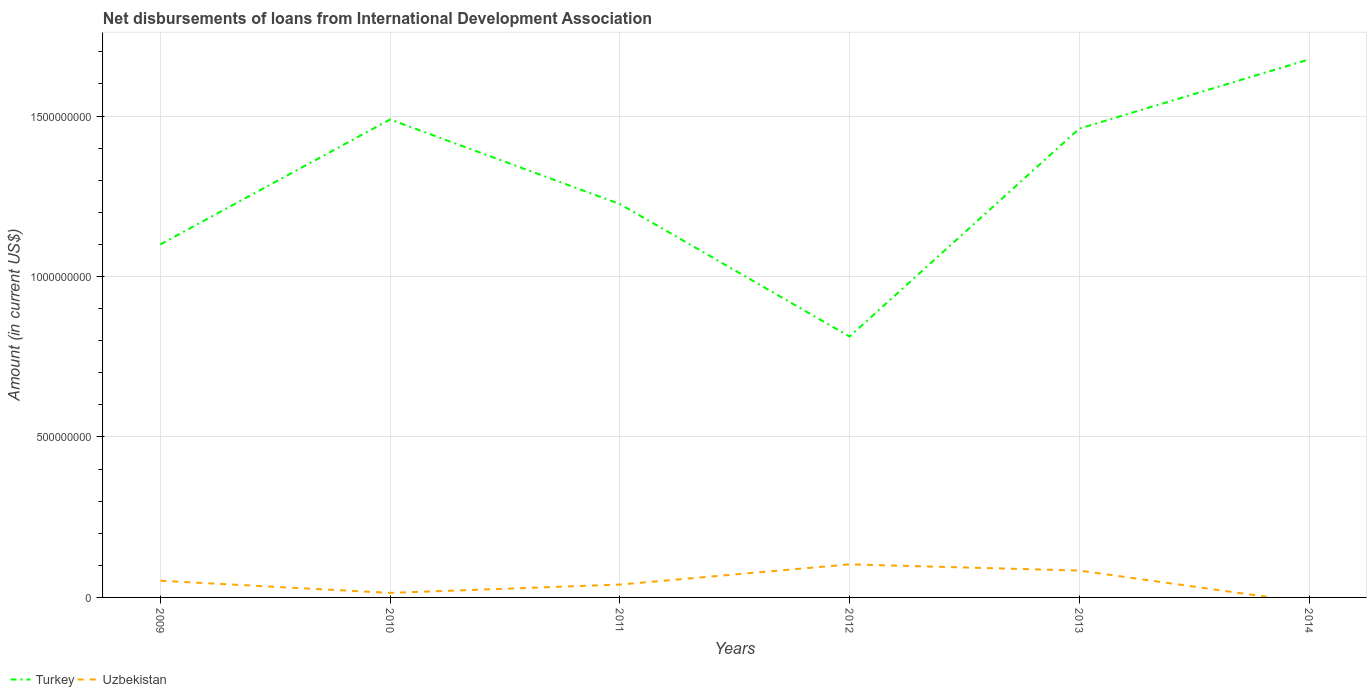How many different coloured lines are there?
Give a very brief answer. 2. What is the total amount of loans disbursed in Uzbekistan in the graph?
Your response must be concise. -3.16e+07. What is the difference between the highest and the second highest amount of loans disbursed in Uzbekistan?
Keep it short and to the point. 1.03e+08. What is the difference between the highest and the lowest amount of loans disbursed in Uzbekistan?
Make the answer very short. 3. How many years are there in the graph?
Offer a terse response. 6. Are the values on the major ticks of Y-axis written in scientific E-notation?
Ensure brevity in your answer.  No. Does the graph contain any zero values?
Your answer should be compact. Yes. How many legend labels are there?
Ensure brevity in your answer.  2. What is the title of the graph?
Give a very brief answer. Net disbursements of loans from International Development Association. What is the label or title of the X-axis?
Keep it short and to the point. Years. What is the Amount (in current US$) of Turkey in 2009?
Your answer should be compact. 1.10e+09. What is the Amount (in current US$) of Uzbekistan in 2009?
Make the answer very short. 5.20e+07. What is the Amount (in current US$) in Turkey in 2010?
Ensure brevity in your answer.  1.49e+09. What is the Amount (in current US$) of Uzbekistan in 2010?
Provide a succinct answer. 1.41e+07. What is the Amount (in current US$) of Turkey in 2011?
Your response must be concise. 1.23e+09. What is the Amount (in current US$) of Uzbekistan in 2011?
Your answer should be compact. 4.01e+07. What is the Amount (in current US$) of Turkey in 2012?
Provide a succinct answer. 8.13e+08. What is the Amount (in current US$) in Uzbekistan in 2012?
Offer a very short reply. 1.03e+08. What is the Amount (in current US$) of Turkey in 2013?
Your answer should be very brief. 1.46e+09. What is the Amount (in current US$) in Uzbekistan in 2013?
Your answer should be very brief. 8.37e+07. What is the Amount (in current US$) of Turkey in 2014?
Your answer should be compact. 1.68e+09. Across all years, what is the maximum Amount (in current US$) in Turkey?
Make the answer very short. 1.68e+09. Across all years, what is the maximum Amount (in current US$) in Uzbekistan?
Offer a terse response. 1.03e+08. Across all years, what is the minimum Amount (in current US$) of Turkey?
Keep it short and to the point. 8.13e+08. Across all years, what is the minimum Amount (in current US$) of Uzbekistan?
Offer a terse response. 0. What is the total Amount (in current US$) in Turkey in the graph?
Your response must be concise. 7.76e+09. What is the total Amount (in current US$) of Uzbekistan in the graph?
Your answer should be very brief. 2.93e+08. What is the difference between the Amount (in current US$) in Turkey in 2009 and that in 2010?
Your answer should be compact. -3.89e+08. What is the difference between the Amount (in current US$) of Uzbekistan in 2009 and that in 2010?
Give a very brief answer. 3.80e+07. What is the difference between the Amount (in current US$) of Turkey in 2009 and that in 2011?
Give a very brief answer. -1.26e+08. What is the difference between the Amount (in current US$) of Uzbekistan in 2009 and that in 2011?
Keep it short and to the point. 1.20e+07. What is the difference between the Amount (in current US$) of Turkey in 2009 and that in 2012?
Offer a terse response. 2.87e+08. What is the difference between the Amount (in current US$) in Uzbekistan in 2009 and that in 2012?
Your answer should be compact. -5.10e+07. What is the difference between the Amount (in current US$) of Turkey in 2009 and that in 2013?
Make the answer very short. -3.61e+08. What is the difference between the Amount (in current US$) in Uzbekistan in 2009 and that in 2013?
Provide a succinct answer. -3.16e+07. What is the difference between the Amount (in current US$) of Turkey in 2009 and that in 2014?
Ensure brevity in your answer.  -5.77e+08. What is the difference between the Amount (in current US$) of Turkey in 2010 and that in 2011?
Keep it short and to the point. 2.64e+08. What is the difference between the Amount (in current US$) of Uzbekistan in 2010 and that in 2011?
Your answer should be very brief. -2.60e+07. What is the difference between the Amount (in current US$) of Turkey in 2010 and that in 2012?
Ensure brevity in your answer.  6.76e+08. What is the difference between the Amount (in current US$) in Uzbekistan in 2010 and that in 2012?
Your answer should be very brief. -8.90e+07. What is the difference between the Amount (in current US$) in Turkey in 2010 and that in 2013?
Keep it short and to the point. 2.84e+07. What is the difference between the Amount (in current US$) in Uzbekistan in 2010 and that in 2013?
Provide a short and direct response. -6.96e+07. What is the difference between the Amount (in current US$) in Turkey in 2010 and that in 2014?
Provide a succinct answer. -1.87e+08. What is the difference between the Amount (in current US$) of Turkey in 2011 and that in 2012?
Your response must be concise. 4.13e+08. What is the difference between the Amount (in current US$) of Uzbekistan in 2011 and that in 2012?
Provide a short and direct response. -6.30e+07. What is the difference between the Amount (in current US$) of Turkey in 2011 and that in 2013?
Your answer should be compact. -2.35e+08. What is the difference between the Amount (in current US$) of Uzbekistan in 2011 and that in 2013?
Offer a terse response. -4.36e+07. What is the difference between the Amount (in current US$) of Turkey in 2011 and that in 2014?
Provide a short and direct response. -4.51e+08. What is the difference between the Amount (in current US$) in Turkey in 2012 and that in 2013?
Ensure brevity in your answer.  -6.48e+08. What is the difference between the Amount (in current US$) in Uzbekistan in 2012 and that in 2013?
Offer a terse response. 1.94e+07. What is the difference between the Amount (in current US$) of Turkey in 2012 and that in 2014?
Provide a short and direct response. -8.64e+08. What is the difference between the Amount (in current US$) of Turkey in 2013 and that in 2014?
Offer a very short reply. -2.15e+08. What is the difference between the Amount (in current US$) of Turkey in 2009 and the Amount (in current US$) of Uzbekistan in 2010?
Ensure brevity in your answer.  1.09e+09. What is the difference between the Amount (in current US$) of Turkey in 2009 and the Amount (in current US$) of Uzbekistan in 2011?
Your response must be concise. 1.06e+09. What is the difference between the Amount (in current US$) of Turkey in 2009 and the Amount (in current US$) of Uzbekistan in 2012?
Ensure brevity in your answer.  9.97e+08. What is the difference between the Amount (in current US$) of Turkey in 2009 and the Amount (in current US$) of Uzbekistan in 2013?
Provide a succinct answer. 1.02e+09. What is the difference between the Amount (in current US$) in Turkey in 2010 and the Amount (in current US$) in Uzbekistan in 2011?
Provide a short and direct response. 1.45e+09. What is the difference between the Amount (in current US$) in Turkey in 2010 and the Amount (in current US$) in Uzbekistan in 2012?
Make the answer very short. 1.39e+09. What is the difference between the Amount (in current US$) of Turkey in 2010 and the Amount (in current US$) of Uzbekistan in 2013?
Offer a very short reply. 1.41e+09. What is the difference between the Amount (in current US$) in Turkey in 2011 and the Amount (in current US$) in Uzbekistan in 2012?
Give a very brief answer. 1.12e+09. What is the difference between the Amount (in current US$) in Turkey in 2011 and the Amount (in current US$) in Uzbekistan in 2013?
Your answer should be very brief. 1.14e+09. What is the difference between the Amount (in current US$) in Turkey in 2012 and the Amount (in current US$) in Uzbekistan in 2013?
Give a very brief answer. 7.29e+08. What is the average Amount (in current US$) in Turkey per year?
Provide a succinct answer. 1.29e+09. What is the average Amount (in current US$) in Uzbekistan per year?
Give a very brief answer. 4.88e+07. In the year 2009, what is the difference between the Amount (in current US$) in Turkey and Amount (in current US$) in Uzbekistan?
Provide a succinct answer. 1.05e+09. In the year 2010, what is the difference between the Amount (in current US$) in Turkey and Amount (in current US$) in Uzbekistan?
Ensure brevity in your answer.  1.48e+09. In the year 2011, what is the difference between the Amount (in current US$) of Turkey and Amount (in current US$) of Uzbekistan?
Give a very brief answer. 1.19e+09. In the year 2012, what is the difference between the Amount (in current US$) of Turkey and Amount (in current US$) of Uzbekistan?
Keep it short and to the point. 7.10e+08. In the year 2013, what is the difference between the Amount (in current US$) of Turkey and Amount (in current US$) of Uzbekistan?
Offer a terse response. 1.38e+09. What is the ratio of the Amount (in current US$) of Turkey in 2009 to that in 2010?
Give a very brief answer. 0.74. What is the ratio of the Amount (in current US$) in Uzbekistan in 2009 to that in 2010?
Your answer should be compact. 3.7. What is the ratio of the Amount (in current US$) in Turkey in 2009 to that in 2011?
Provide a short and direct response. 0.9. What is the ratio of the Amount (in current US$) of Uzbekistan in 2009 to that in 2011?
Keep it short and to the point. 1.3. What is the ratio of the Amount (in current US$) in Turkey in 2009 to that in 2012?
Your response must be concise. 1.35. What is the ratio of the Amount (in current US$) of Uzbekistan in 2009 to that in 2012?
Your answer should be compact. 0.51. What is the ratio of the Amount (in current US$) in Turkey in 2009 to that in 2013?
Provide a succinct answer. 0.75. What is the ratio of the Amount (in current US$) in Uzbekistan in 2009 to that in 2013?
Provide a short and direct response. 0.62. What is the ratio of the Amount (in current US$) of Turkey in 2009 to that in 2014?
Ensure brevity in your answer.  0.66. What is the ratio of the Amount (in current US$) in Turkey in 2010 to that in 2011?
Provide a succinct answer. 1.22. What is the ratio of the Amount (in current US$) of Uzbekistan in 2010 to that in 2011?
Give a very brief answer. 0.35. What is the ratio of the Amount (in current US$) in Turkey in 2010 to that in 2012?
Make the answer very short. 1.83. What is the ratio of the Amount (in current US$) in Uzbekistan in 2010 to that in 2012?
Provide a succinct answer. 0.14. What is the ratio of the Amount (in current US$) in Turkey in 2010 to that in 2013?
Provide a short and direct response. 1.02. What is the ratio of the Amount (in current US$) of Uzbekistan in 2010 to that in 2013?
Make the answer very short. 0.17. What is the ratio of the Amount (in current US$) of Turkey in 2010 to that in 2014?
Your answer should be very brief. 0.89. What is the ratio of the Amount (in current US$) in Turkey in 2011 to that in 2012?
Give a very brief answer. 1.51. What is the ratio of the Amount (in current US$) of Uzbekistan in 2011 to that in 2012?
Your answer should be very brief. 0.39. What is the ratio of the Amount (in current US$) in Turkey in 2011 to that in 2013?
Offer a terse response. 0.84. What is the ratio of the Amount (in current US$) in Uzbekistan in 2011 to that in 2013?
Your answer should be compact. 0.48. What is the ratio of the Amount (in current US$) in Turkey in 2011 to that in 2014?
Keep it short and to the point. 0.73. What is the ratio of the Amount (in current US$) of Turkey in 2012 to that in 2013?
Your answer should be compact. 0.56. What is the ratio of the Amount (in current US$) of Uzbekistan in 2012 to that in 2013?
Keep it short and to the point. 1.23. What is the ratio of the Amount (in current US$) of Turkey in 2012 to that in 2014?
Ensure brevity in your answer.  0.48. What is the ratio of the Amount (in current US$) of Turkey in 2013 to that in 2014?
Offer a very short reply. 0.87. What is the difference between the highest and the second highest Amount (in current US$) of Turkey?
Ensure brevity in your answer.  1.87e+08. What is the difference between the highest and the second highest Amount (in current US$) of Uzbekistan?
Offer a very short reply. 1.94e+07. What is the difference between the highest and the lowest Amount (in current US$) in Turkey?
Offer a very short reply. 8.64e+08. What is the difference between the highest and the lowest Amount (in current US$) in Uzbekistan?
Give a very brief answer. 1.03e+08. 